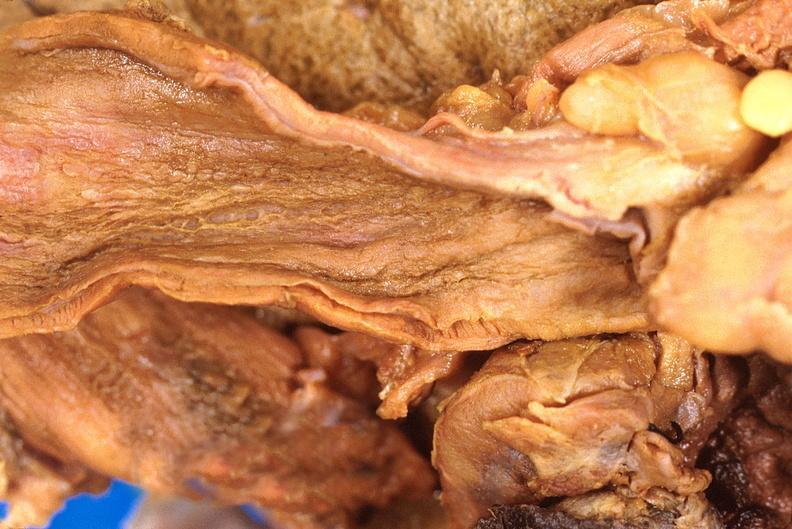what does this image show?
Answer the question using a single word or phrase. Stomach 